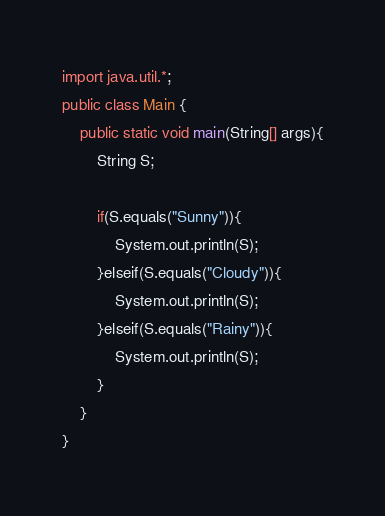Convert code to text. <code><loc_0><loc_0><loc_500><loc_500><_Java_>import java.util.*;
public class Main {
	public static void main(String[] args){
		String S;

		if(S.equals("Sunny")){
			System.out.println(S);
		}elseif(S.equals("Cloudy")){
			System.out.println(S);
		}elseif(S.equals("Rainy")){
			System.out.println(S);
		}
	}
}</code> 